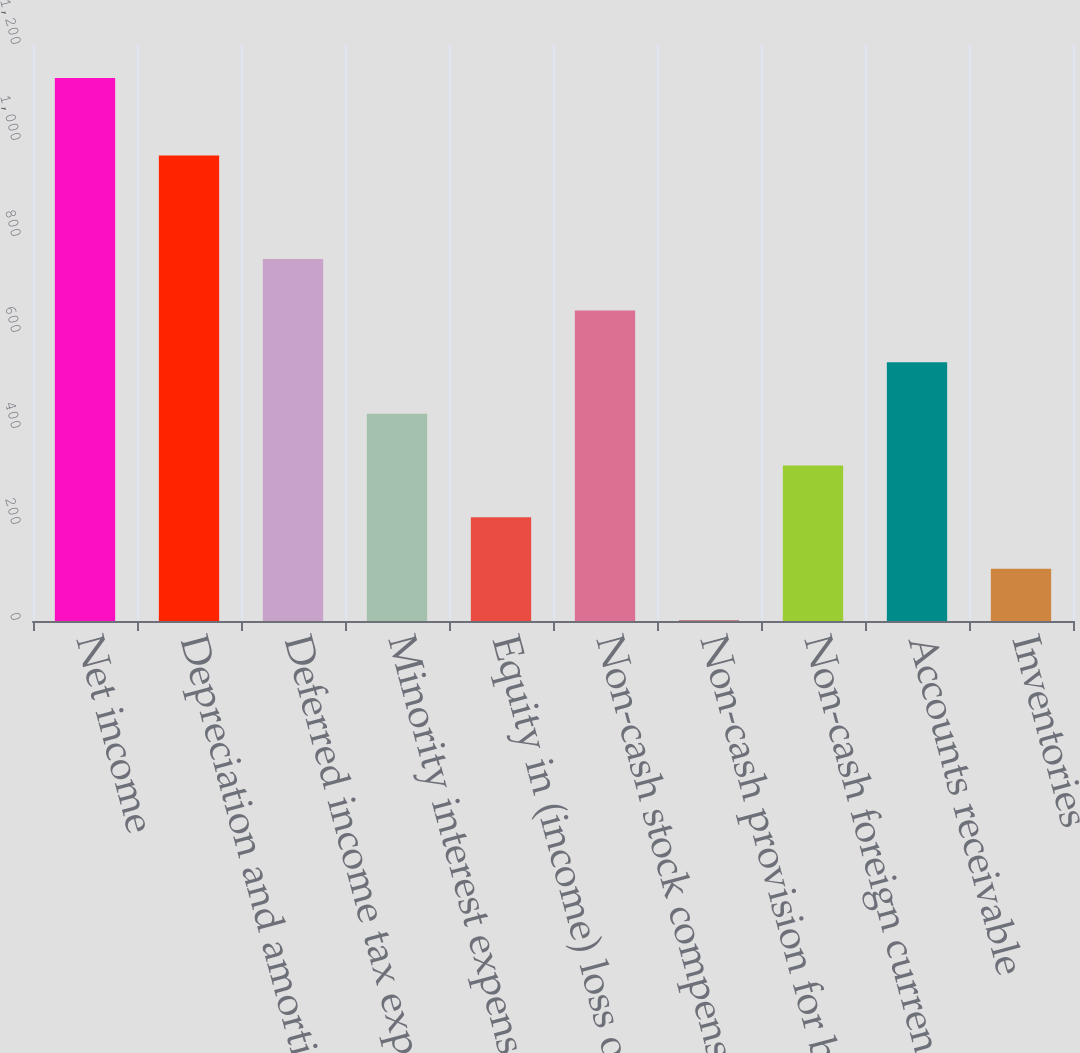Convert chart to OTSL. <chart><loc_0><loc_0><loc_500><loc_500><bar_chart><fcel>Net income<fcel>Depreciation and amortization<fcel>Deferred income tax expense<fcel>Minority interest expense<fcel>Equity in (income) loss of<fcel>Non-cash stock compensation<fcel>Non-cash provision for bad<fcel>Non-cash foreign currency<fcel>Accounts receivable<fcel>Inventories<nl><fcel>1131<fcel>969.6<fcel>754.4<fcel>431.6<fcel>216.4<fcel>646.8<fcel>1.2<fcel>324<fcel>539.2<fcel>108.8<nl></chart> 